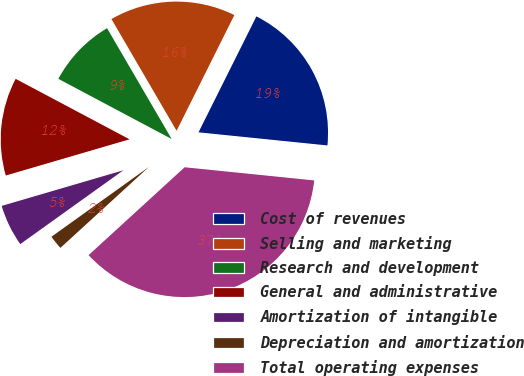Convert chart to OTSL. <chart><loc_0><loc_0><loc_500><loc_500><pie_chart><fcel>Cost of revenues<fcel>Selling and marketing<fcel>Research and development<fcel>General and administrative<fcel>Amortization of intangible<fcel>Depreciation and amortization<fcel>Total operating expenses<nl><fcel>19.24%<fcel>15.77%<fcel>8.83%<fcel>12.3%<fcel>5.36%<fcel>1.9%<fcel>36.59%<nl></chart> 